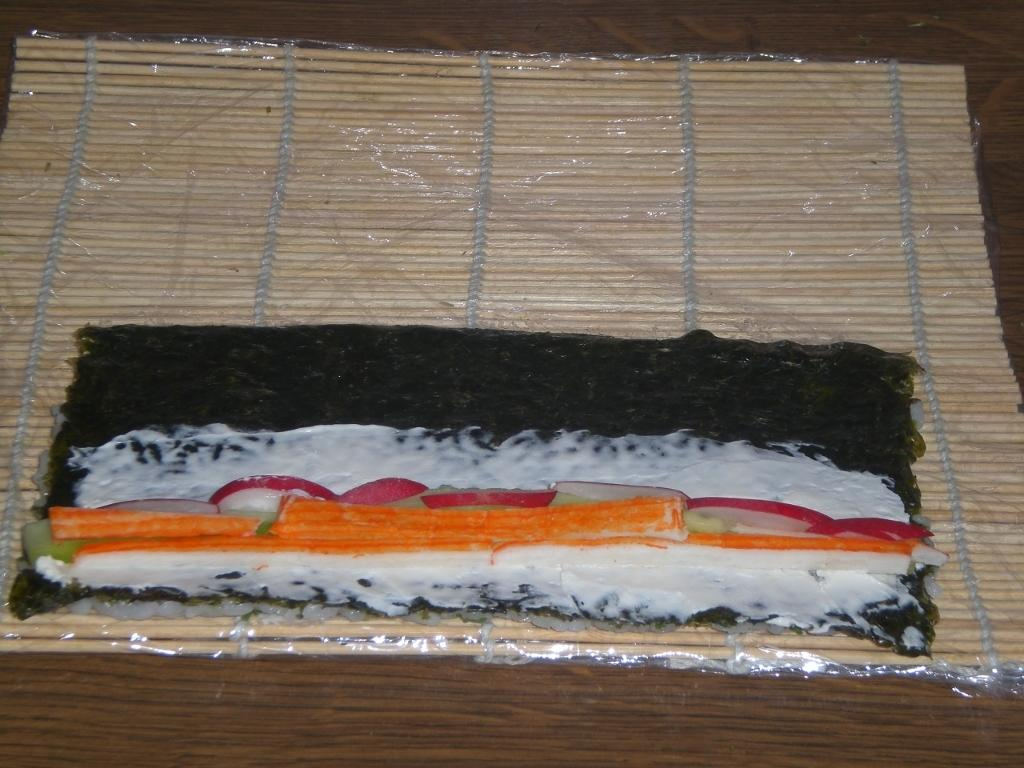What type of food is on the bamboo-sticks in the image? The facts provided do not specify the type of food on the bamboo-sticks. What is the color of the surface on which the food is placed? The food is on a brown color surface. What type of soap is being used to clean the throat in the image? There is no soap or throat-cleaning activity depicted in the image. 